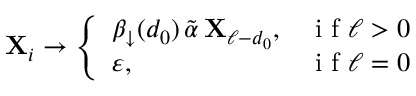Convert formula to latex. <formula><loc_0><loc_0><loc_500><loc_500>X _ { i } \to \left \{ \begin{array} { l l } { \beta _ { \downarrow } ( d _ { 0 } ) \, \tilde { \alpha } \, X _ { \ell - d _ { 0 } } , } & { i f \ell > 0 } \\ { \varepsilon , } & { i f \ell = 0 } \end{array}</formula> 